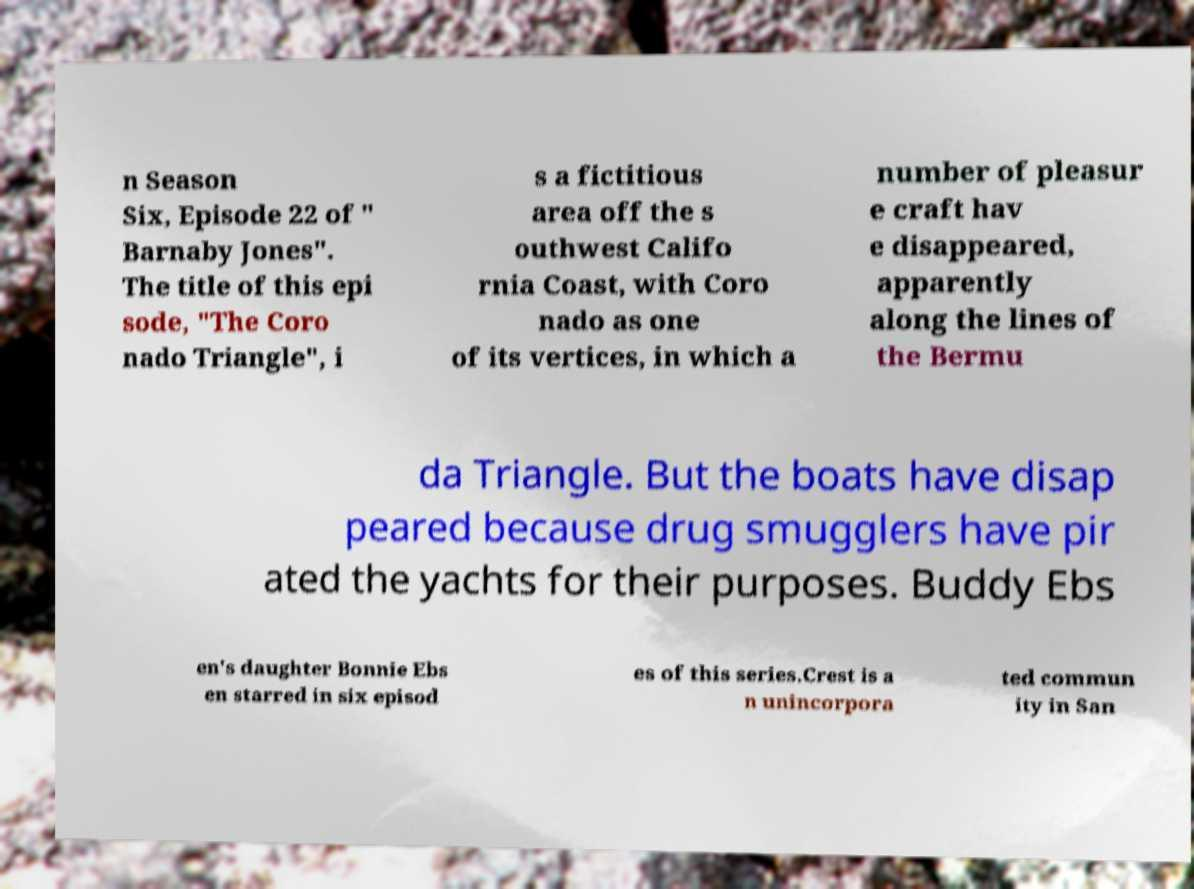Can you accurately transcribe the text from the provided image for me? n Season Six, Episode 22 of " Barnaby Jones". The title of this epi sode, "The Coro nado Triangle", i s a fictitious area off the s outhwest Califo rnia Coast, with Coro nado as one of its vertices, in which a number of pleasur e craft hav e disappeared, apparently along the lines of the Bermu da Triangle. But the boats have disap peared because drug smugglers have pir ated the yachts for their purposes. Buddy Ebs en's daughter Bonnie Ebs en starred in six episod es of this series.Crest is a n unincorpora ted commun ity in San 